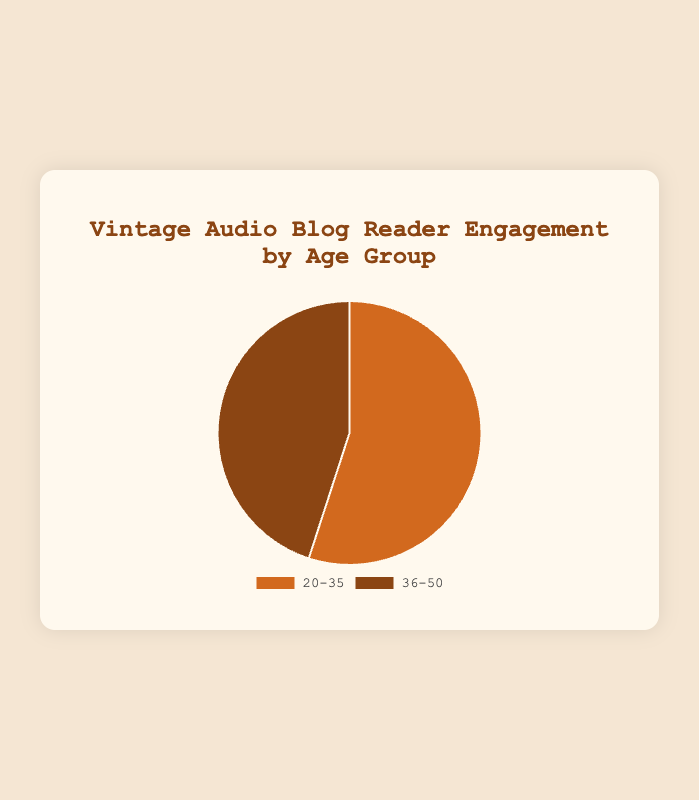Which age group has the highest reader engagement? The age groups shown are '20-35' and '36-50'. By looking at the percentage values in the pie chart, '20-35' has a 55% engagement, which is higher than '36-50' with 45%.
Answer: 20-35 What is the difference in reader engagement between the two age groups? The '20-35' age group has 55% engagement and the '36-50' age group has 45% engagement. Subtracting the smaller number from the larger, 55% - 45%, gives a difference of 10%.
Answer: 10% What is the total percentage represented by both age groups? Adding the percentages of both age groups, '20-35' with 55% and '36-50' with 45%, gives 55% + 45% = 100%.
Answer: 100% Which age group has a higher average time spent on the blog? The '20-35' age group spends an average of 15.8 minutes on the blog, whereas the '36-50' age group spends an average of 12.4 minutes. 15.8 is greater than 12.4, so '20-35' spends more time.
Answer: 20-35 What is the ratio of '20-35' comments to '36-50' comments? The '20-35' age group has 120 comments and the '36-50' age group has 100 comments. The ratio is 120:100, which can be simplified by dividing both numbers by 20, resulting in a ratio of 6:5.
Answer: 6:5 Which age group visits more pages on average? The '20-35' age group visits an average of 4.5 pages, and the '36-50' age group visits an average of 3.8 pages. Therefore, '20-35' visits more pages on average.
Answer: 20-35 What is the average reader engagement percentage of the two age groups combined? Adding the engagement percentages of the age groups gives 55% + 45% = 100%. Dividing this by 2 (as there are two age groups) gives an average engagement percentage of 50%.
Answer: 50% Which age group is represented by the lighter color on the pie chart? The pie chart displays two colors: the lighter color represents the '20-35' age group.
Answer: 20-35 By what percentage does the younger age group (20-35) exceed the older age group (36-50) in average number of pages visited? The '20-35' age group averages 4.5 pages while '36-50' averages 3.8 pages. The difference is 4.5 - 3.8 = 0.7 pages. To find the percentage increase relative to '36-50', we compute (0.7 / 3.8) * 100 ≈ 18.42%.
Answer: 18.42% What is the combined number of comments from both age groups? The '20-35' age group made 120 comments and the '36-50' age group made 100 comments. The combined number of comments is 120 + 100 = 220.
Answer: 220 